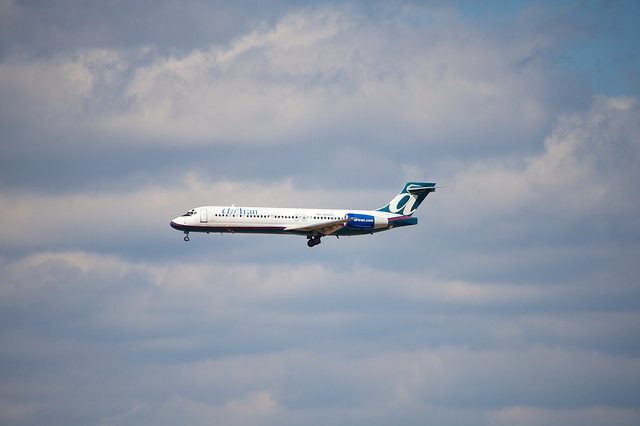Describe the objects in this image and their specific colors. I can see a airplane in gray, white, black, and darkgray tones in this image. 